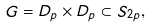<formula> <loc_0><loc_0><loc_500><loc_500>\ G = D _ { p } \times D _ { p } \subset S _ { 2 p } ,</formula> 